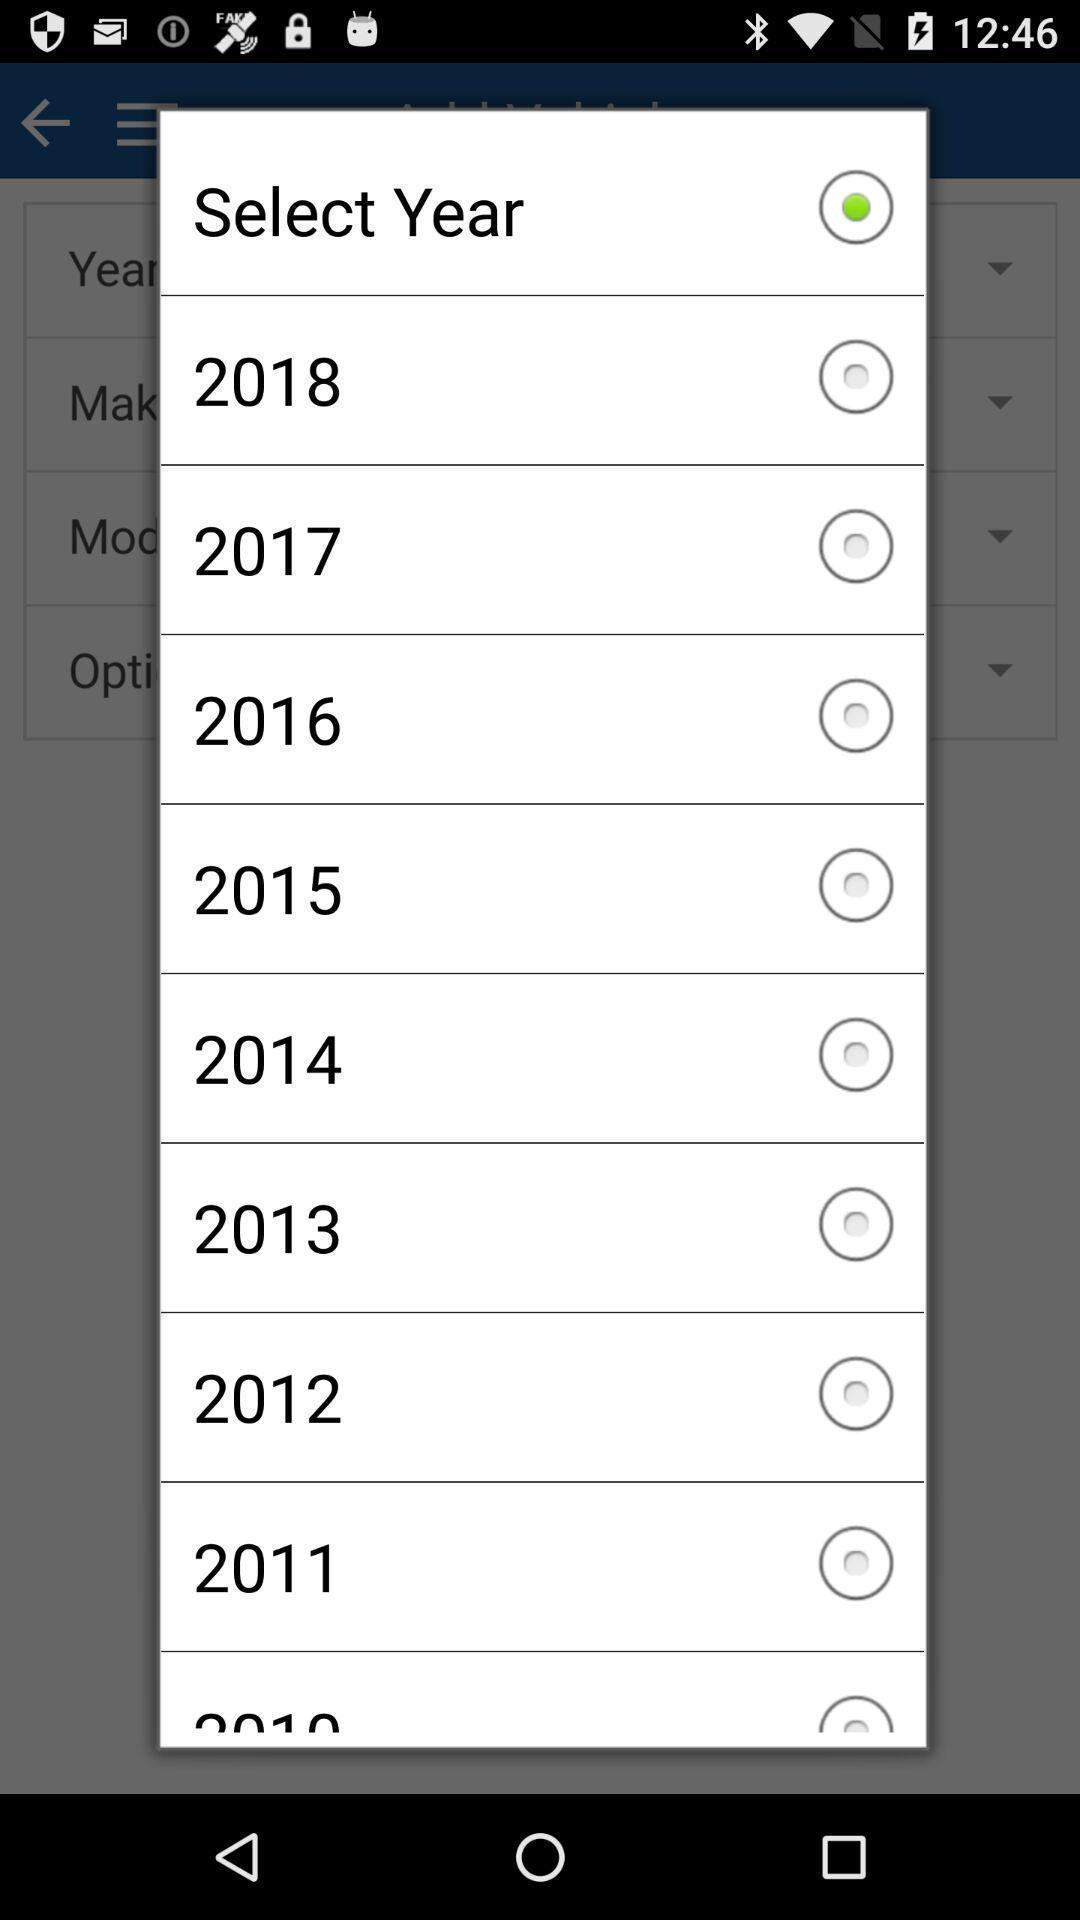Give me a narrative description of this picture. Popup displaying different options for selecting year in car application. 